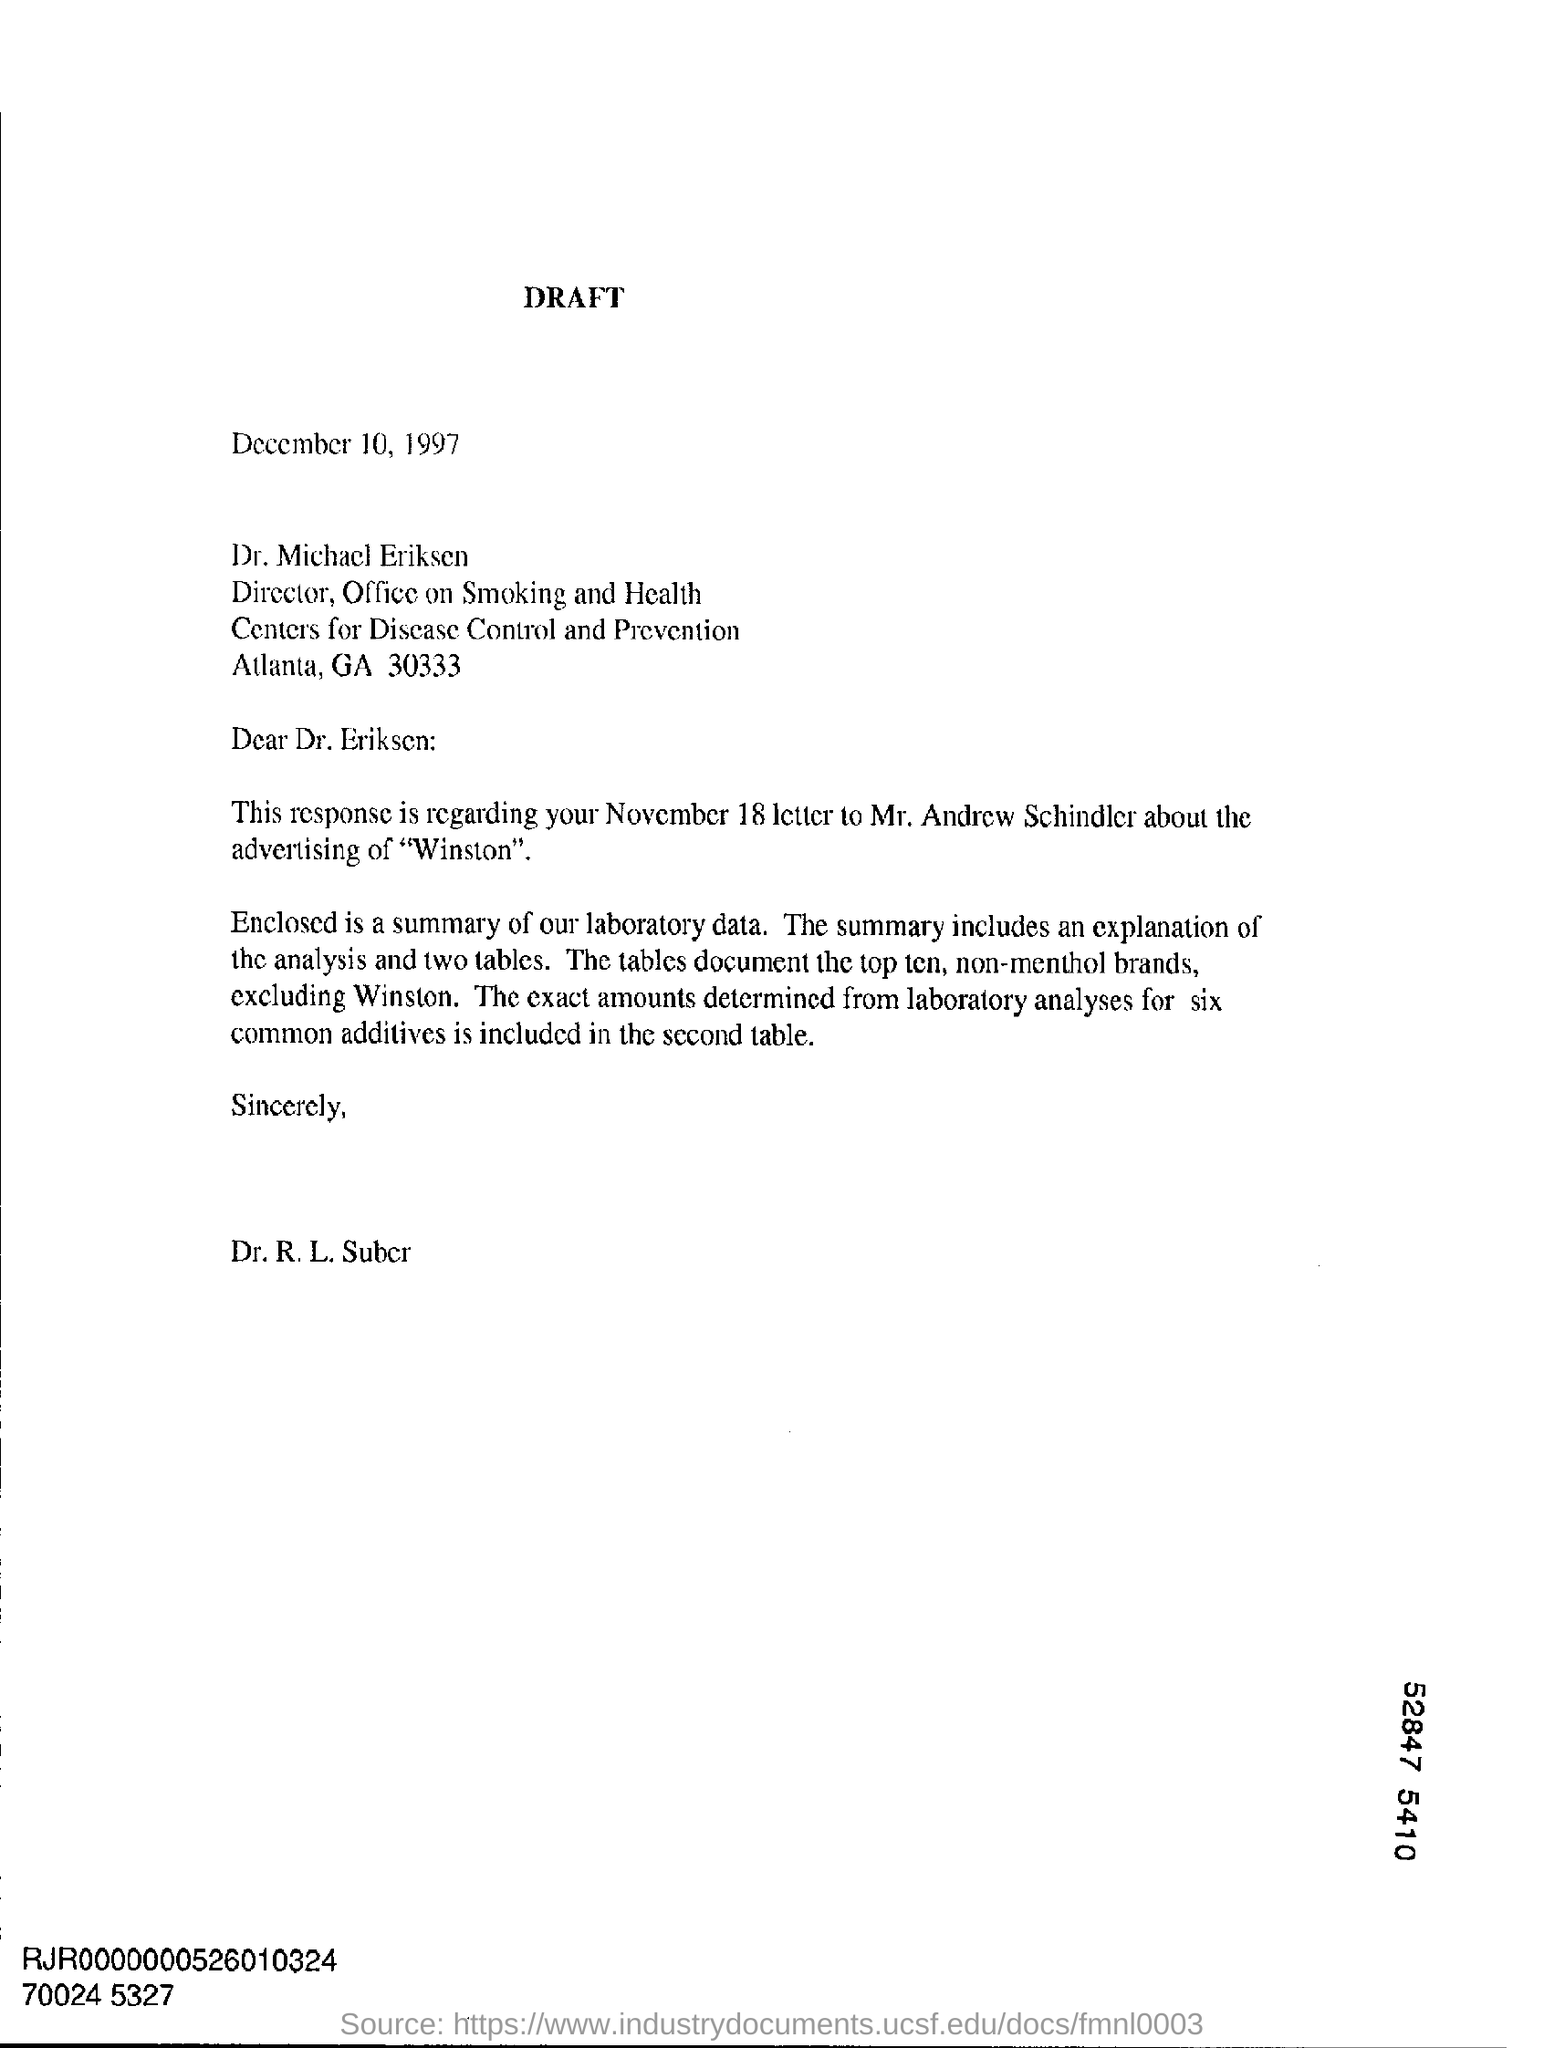To Whom is this letter addressed to?
Offer a terse response. Dr . Michael Eriksen. What is the date on the document?
Offer a very short reply. December 10, 1997. 